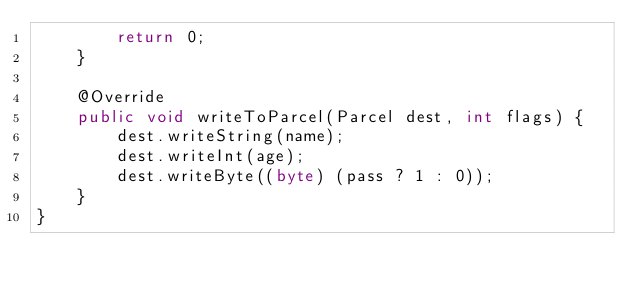Convert code to text. <code><loc_0><loc_0><loc_500><loc_500><_Java_>        return 0;
    }

    @Override
    public void writeToParcel(Parcel dest, int flags) {
        dest.writeString(name);
        dest.writeInt(age);
        dest.writeByte((byte) (pass ? 1 : 0));
    }
}
</code> 